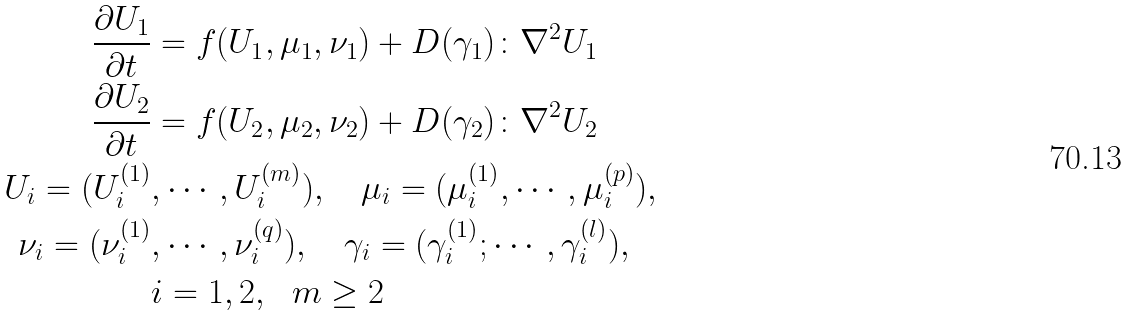Convert formula to latex. <formula><loc_0><loc_0><loc_500><loc_500>\frac { \partial U _ { 1 } } { \partial t } & = f ( U _ { 1 } , \mu _ { 1 } , \nu _ { 1 } ) + D ( \gamma _ { 1 } ) \colon \nabla ^ { 2 } U _ { 1 } \\ \frac { \partial U _ { 2 } } { \partial t } & = f ( U _ { 2 } , \mu _ { 2 } , \nu _ { 2 } ) + D ( \gamma _ { 2 } ) \colon \nabla ^ { 2 } U _ { 2 } \\ U _ { i } = ( U _ { i } ^ { ( 1 ) } & , \cdots , U _ { i } ^ { ( m ) } ) , \quad \mu _ { i } = ( \mu _ { i } ^ { ( 1 ) } , \cdots , \mu _ { i } ^ { ( p ) } ) , \\ \nu _ { i } = ( \nu _ { i } ^ { ( 1 ) } & , \cdots , \nu _ { i } ^ { ( q ) } ) , \quad \gamma _ { i } = ( \gamma _ { i } ^ { ( 1 ) } ; \cdots , \gamma _ { i } ^ { ( l ) } ) , \\ & i = 1 , 2 , \ \ m \geq 2</formula> 